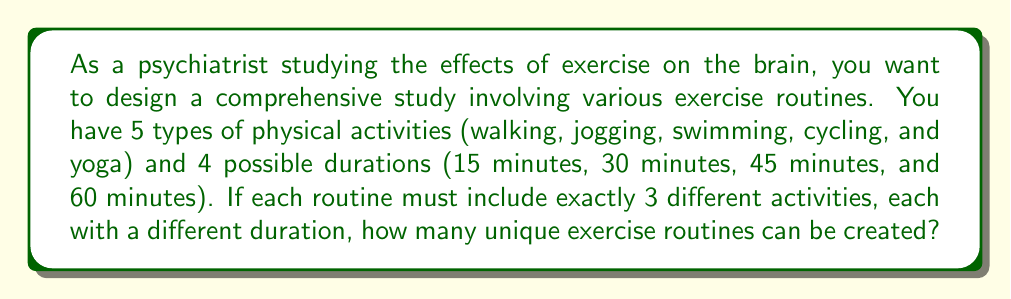Show me your answer to this math problem. To solve this problem, we'll use the multiplication principle of counting and permutations. Let's break it down step-by-step:

1. First, we need to choose 3 activities out of the 5 available. This is a combination problem, represented as $\binom{5}{3}$.

   $\binom{5}{3} = \frac{5!}{3!(5-3)!} = \frac{5!}{3!2!} = 10$

2. Next, we need to arrange these 3 chosen activities. Since the order matters (as each activity will be assigned a different duration), this is a permutation of 3, which is simply $3! = 6$.

3. Finally, we need to assign durations to these activities. We have 4 durations to choose from, and we need to select 3 of them without repetition. This is a permutation of 3 items from 4, represented as $P(4,3)$.

   $P(4,3) = \frac{4!}{(4-3)!} = \frac{4!}{1!} = 24$

4. By the multiplication principle, the total number of unique exercise routines is the product of these three factors:

   $10 \times 6 \times 24 = 1,440$

Therefore, there are 1,440 possible unique exercise routines that can be created under these conditions.
Answer: 1,440 unique exercise routines 